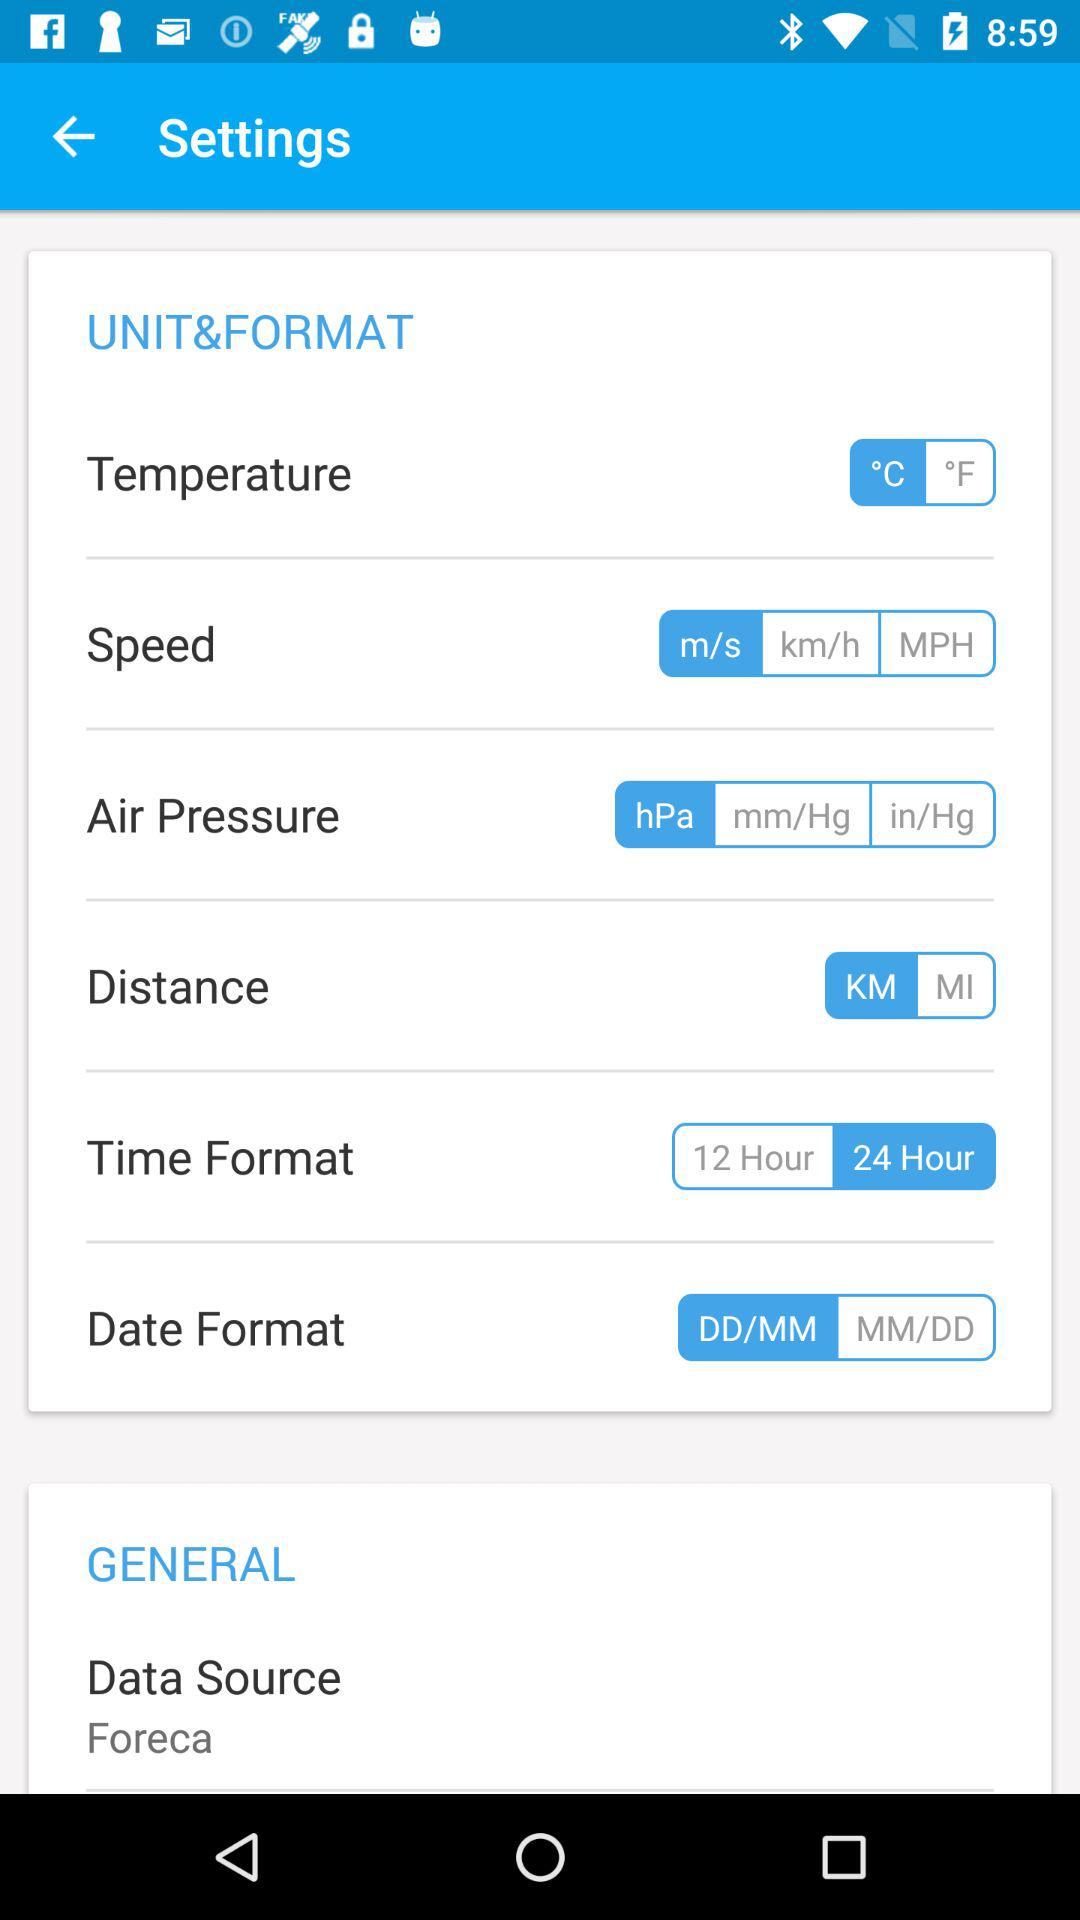What date format has been chosen? The chosen date format is "DD/MM". 